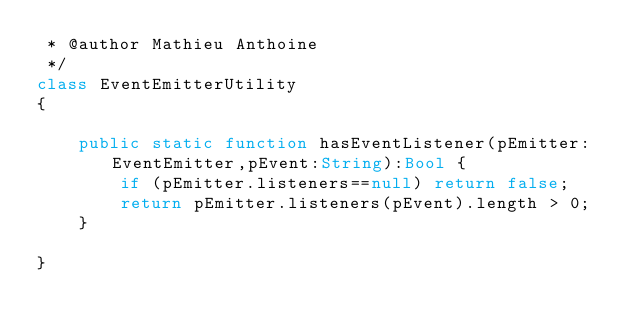Convert code to text. <code><loc_0><loc_0><loc_500><loc_500><_Haxe_> * @author Mathieu Anthoine
 */
class EventEmitterUtility
{

	public static function hasEventListener(pEmitter:EventEmitter,pEvent:String):Bool {
		if (pEmitter.listeners==null) return false;
		return pEmitter.listeners(pEvent).length > 0;
	}
	
}</code> 